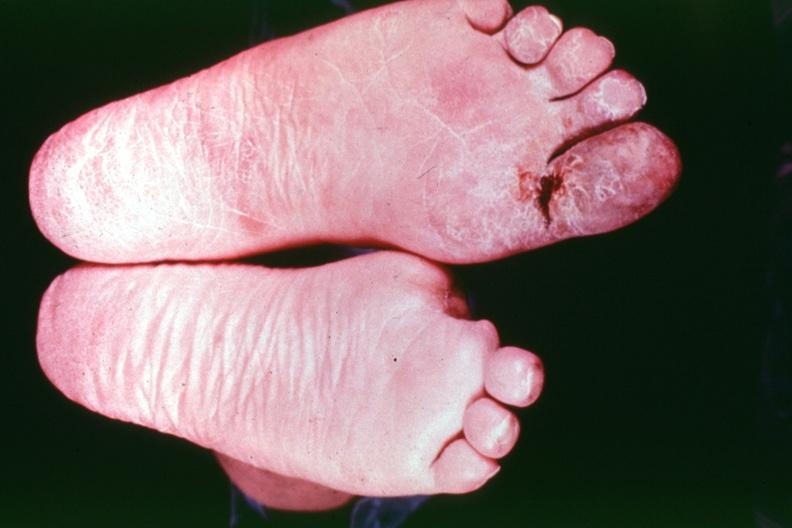what is present?
Answer the question using a single word or phrase. Feet 